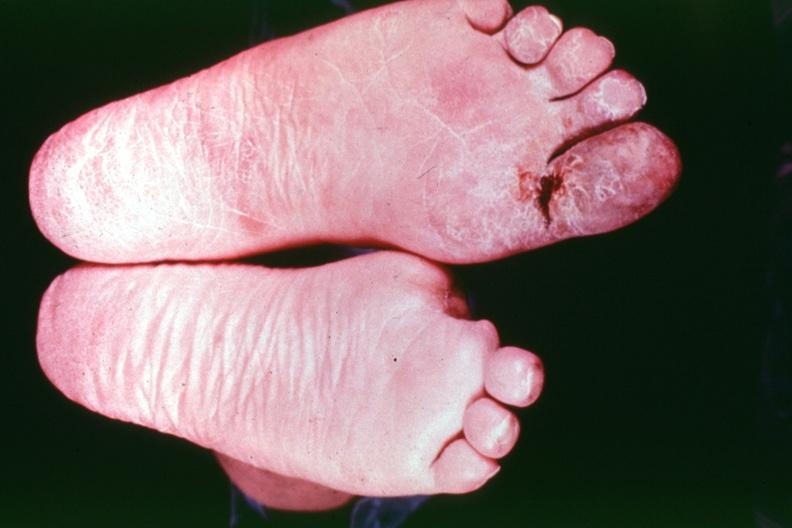what is present?
Answer the question using a single word or phrase. Feet 